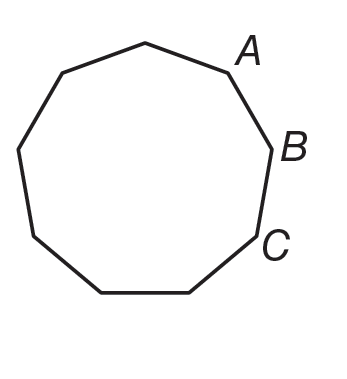Answer the mathemtical geometry problem and directly provide the correct option letter.
Question: If the polygon shown is regular, what is m \angle A B C.
Choices: A: 140 B: 144 C: 162 D: 180 A 